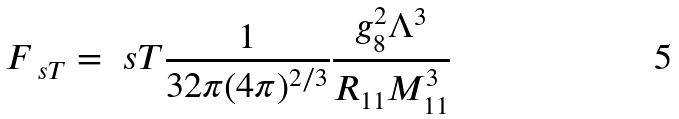Convert formula to latex. <formula><loc_0><loc_0><loc_500><loc_500>F _ { \ s T } = { \ s T } \frac { 1 } { 3 2 \pi ( 4 \pi ) ^ { 2 / 3 } } \frac { g _ { 8 } ^ { 2 } \Lambda ^ { 3 } } { R _ { 1 1 } M _ { 1 1 } ^ { 3 } }</formula> 